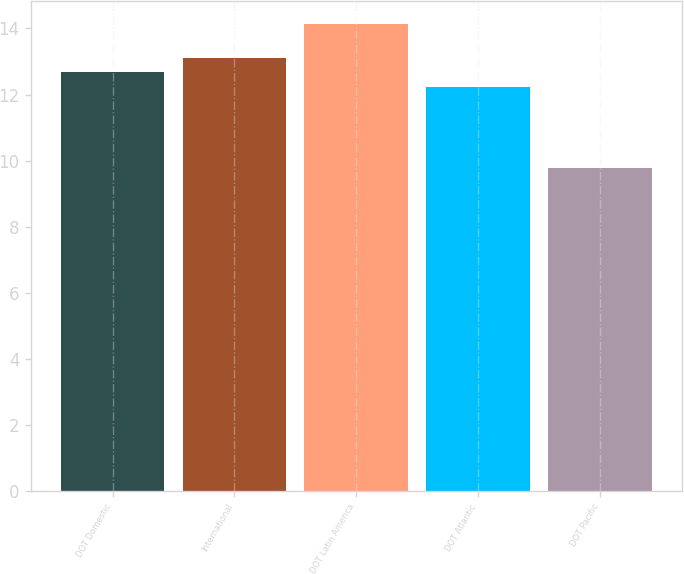Convert chart. <chart><loc_0><loc_0><loc_500><loc_500><bar_chart><fcel>DOT Domestic<fcel>International<fcel>DOT Latin America<fcel>DOT Atlantic<fcel>DOT Pacific<nl><fcel>12.67<fcel>13.11<fcel>14.13<fcel>12.23<fcel>9.77<nl></chart> 